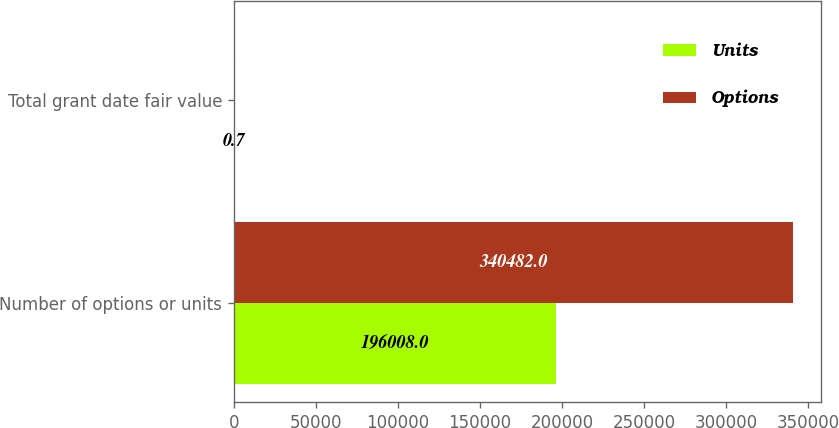Convert chart to OTSL. <chart><loc_0><loc_0><loc_500><loc_500><stacked_bar_chart><ecel><fcel>Number of options or units<fcel>Total grant date fair value<nl><fcel>Units<fcel>196008<fcel>0.7<nl><fcel>Options<fcel>340482<fcel>6.7<nl></chart> 